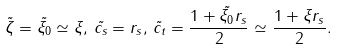Convert formula to latex. <formula><loc_0><loc_0><loc_500><loc_500>\tilde { \zeta } = \tilde { \xi _ { 0 } } \simeq \xi , \, \tilde { c _ { s } } = r _ { s } , \, \tilde { c _ { t } } = \frac { 1 + \tilde { \xi _ { 0 } } r _ { s } } { 2 } \simeq \frac { 1 + \xi r _ { s } } { 2 } .</formula> 